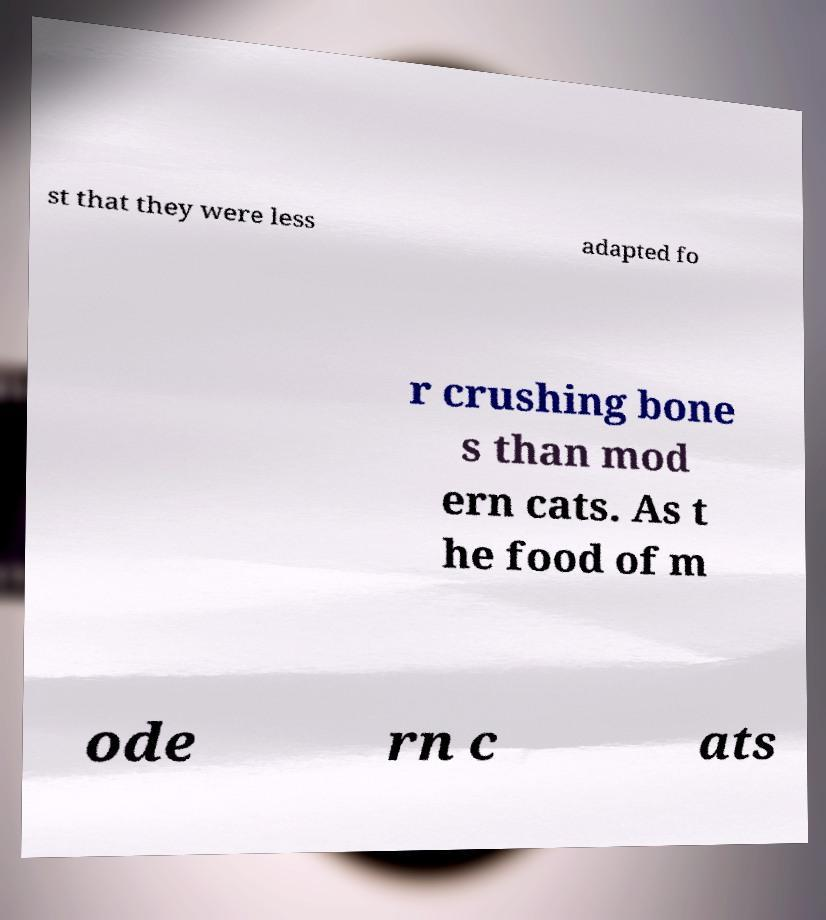Can you accurately transcribe the text from the provided image for me? st that they were less adapted fo r crushing bone s than mod ern cats. As t he food of m ode rn c ats 